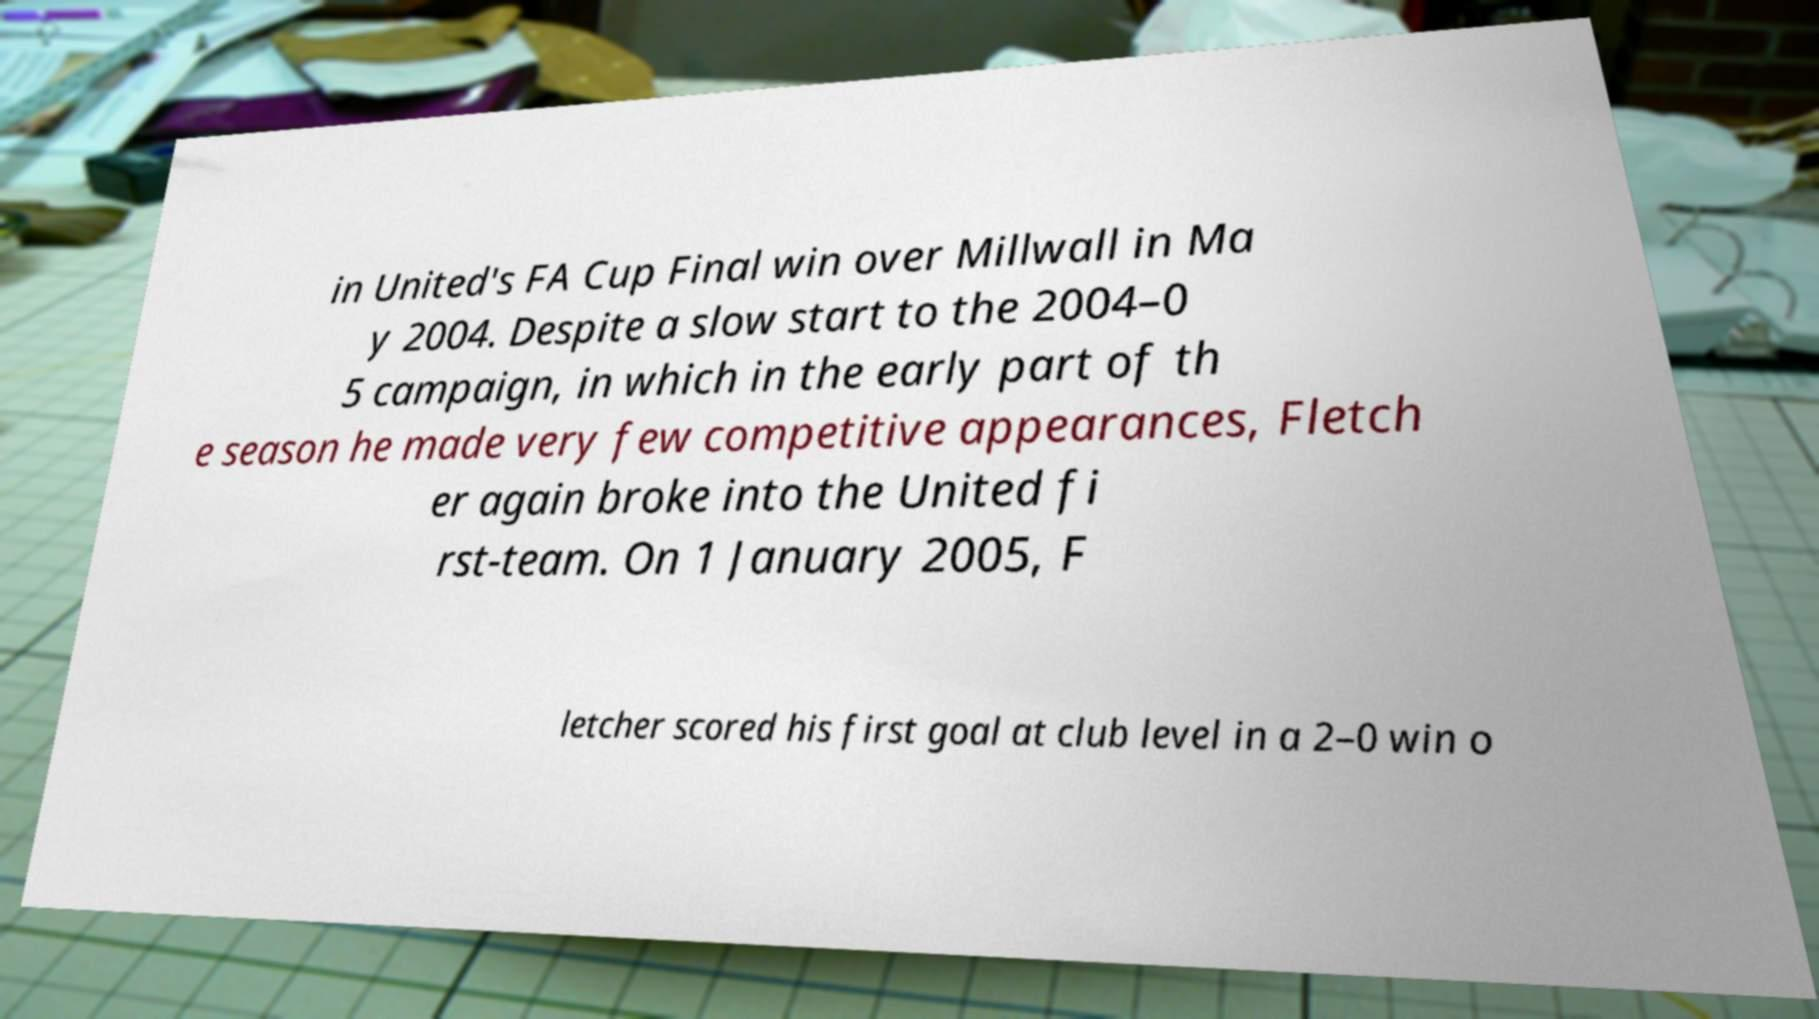For documentation purposes, I need the text within this image transcribed. Could you provide that? in United's FA Cup Final win over Millwall in Ma y 2004. Despite a slow start to the 2004–0 5 campaign, in which in the early part of th e season he made very few competitive appearances, Fletch er again broke into the United fi rst-team. On 1 January 2005, F letcher scored his first goal at club level in a 2–0 win o 